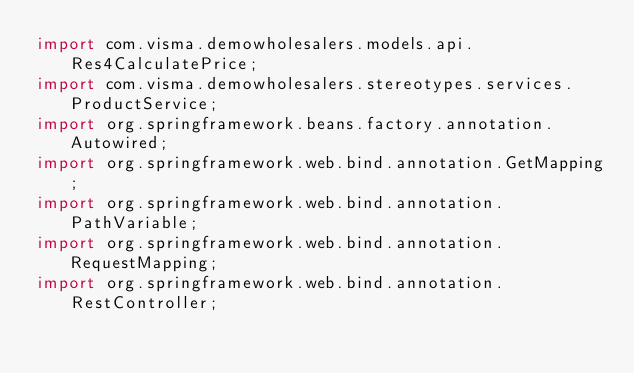Convert code to text. <code><loc_0><loc_0><loc_500><loc_500><_Java_>import com.visma.demowholesalers.models.api.Res4CalculatePrice;
import com.visma.demowholesalers.stereotypes.services.ProductService;
import org.springframework.beans.factory.annotation.Autowired;
import org.springframework.web.bind.annotation.GetMapping;
import org.springframework.web.bind.annotation.PathVariable;
import org.springframework.web.bind.annotation.RequestMapping;
import org.springframework.web.bind.annotation.RestController;
</code> 